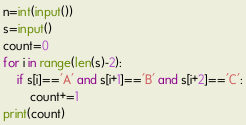Convert code to text. <code><loc_0><loc_0><loc_500><loc_500><_Python_>n=int(input())
s=input()
count=0
for i in range(len(s)-2):
    if s[i]=='A' and s[i+1]=='B' and s[i+2]=='C':
        count+=1
print(count)</code> 